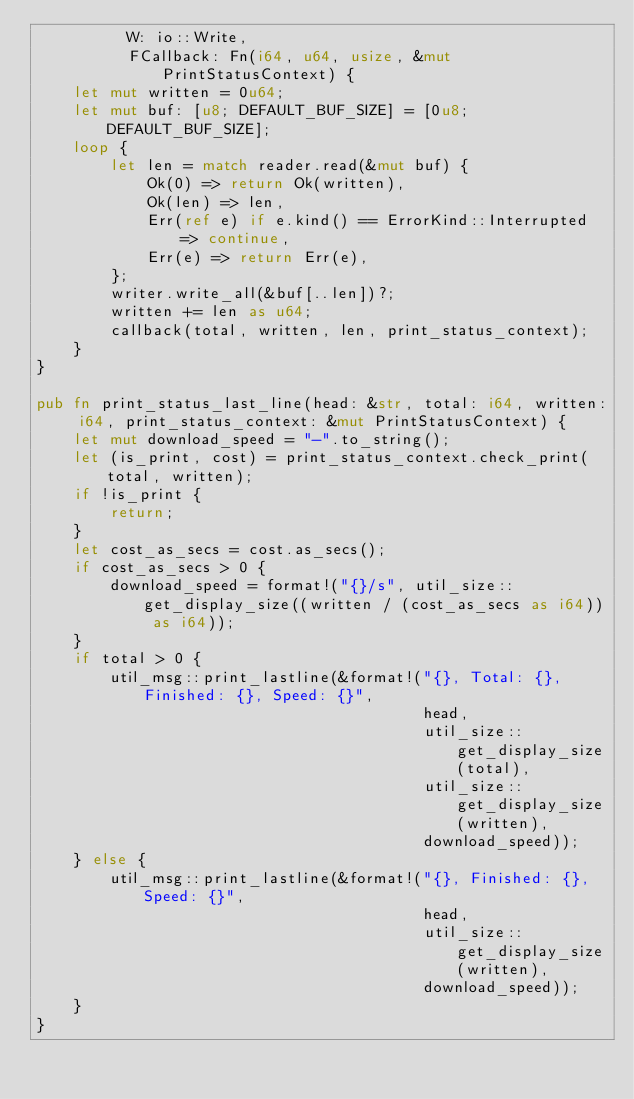<code> <loc_0><loc_0><loc_500><loc_500><_Rust_>          W: io::Write,
          FCallback: Fn(i64, u64, usize, &mut PrintStatusContext) {
    let mut written = 0u64;
    let mut buf: [u8; DEFAULT_BUF_SIZE] = [0u8; DEFAULT_BUF_SIZE];
    loop {
        let len = match reader.read(&mut buf) {
            Ok(0) => return Ok(written),
            Ok(len) => len,
            Err(ref e) if e.kind() == ErrorKind::Interrupted => continue,
            Err(e) => return Err(e),
        };
        writer.write_all(&buf[..len])?;
        written += len as u64;
        callback(total, written, len, print_status_context);
    }
}

pub fn print_status_last_line(head: &str, total: i64, written: i64, print_status_context: &mut PrintStatusContext) {
    let mut download_speed = "-".to_string();
    let (is_print, cost) = print_status_context.check_print(total, written);
    if !is_print {
        return;
    }
    let cost_as_secs = cost.as_secs();
    if cost_as_secs > 0 {
        download_speed = format!("{}/s", util_size::get_display_size((written / (cost_as_secs as i64)) as i64));
    }
    if total > 0 {
        util_msg::print_lastline(&format!("{}, Total: {}, Finished: {}, Speed: {}",
                                          head,
                                          util_size::get_display_size(total),
                                          util_size::get_display_size(written),
                                          download_speed));
    } else {
        util_msg::print_lastline(&format!("{}, Finished: {}, Speed: {}",
                                          head,
                                          util_size::get_display_size(written),
                                          download_speed));
    }
}
</code> 